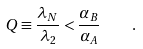Convert formula to latex. <formula><loc_0><loc_0><loc_500><loc_500>Q \equiv \frac { \lambda _ { N } } { \lambda _ { 2 } } < \frac { \alpha _ { B } } { \alpha _ { A } } \quad .</formula> 